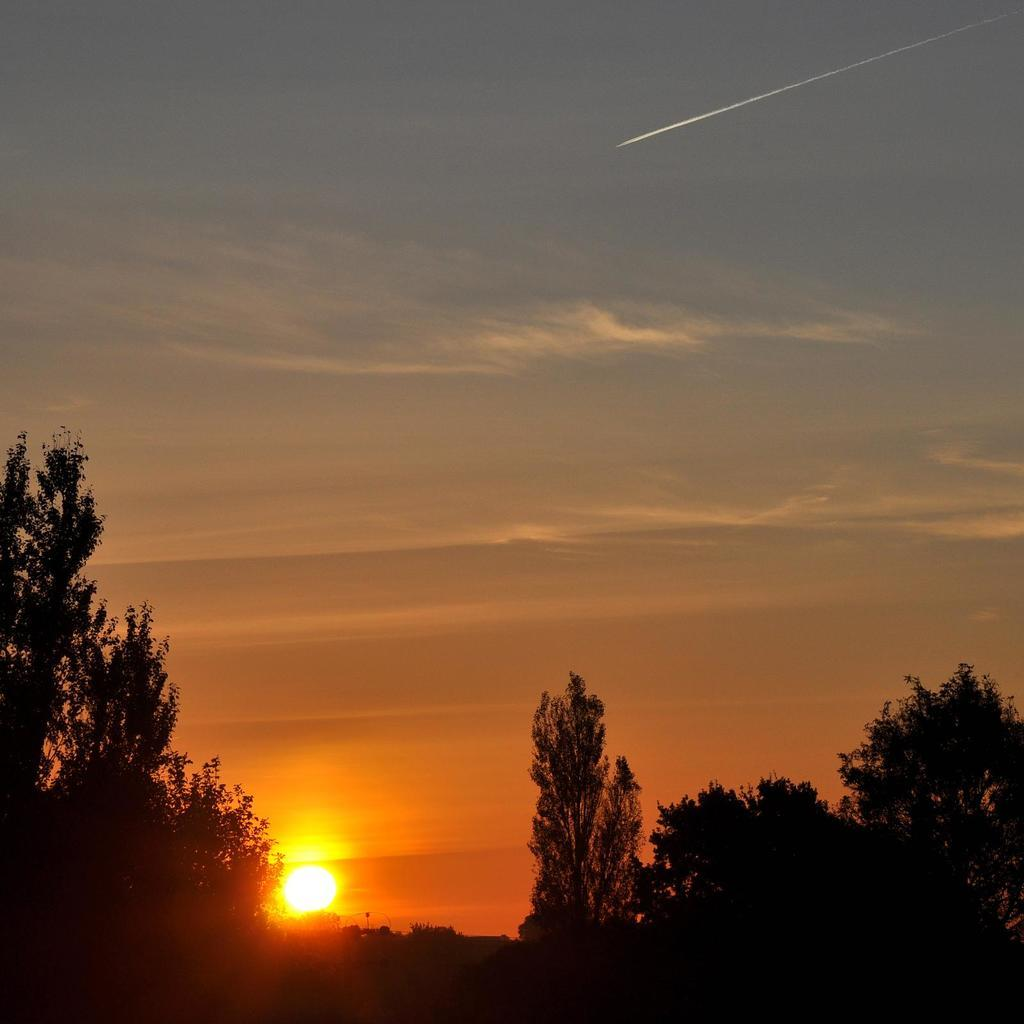What type of vegetation is at the bottom of the picture? There are trees at the bottom of the picture. What celestial body can be seen in the background? The sun is visible in the background. What is located at the top of the picture? The sky is at the top of the picture. What is the color of the sky in the image? The color of the sky is blue. How many questions are being asked in the image? There are no questions visible in the image, as it is a picture and not a text-based medium. 